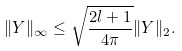<formula> <loc_0><loc_0><loc_500><loc_500>\| Y \| _ { \infty } \leq \sqrt { \frac { 2 l + 1 } { 4 \pi } } \| Y \| _ { 2 } .</formula> 